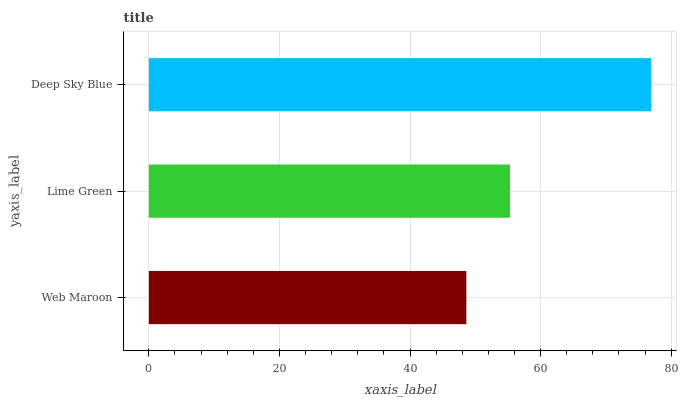Is Web Maroon the minimum?
Answer yes or no. Yes. Is Deep Sky Blue the maximum?
Answer yes or no. Yes. Is Lime Green the minimum?
Answer yes or no. No. Is Lime Green the maximum?
Answer yes or no. No. Is Lime Green greater than Web Maroon?
Answer yes or no. Yes. Is Web Maroon less than Lime Green?
Answer yes or no. Yes. Is Web Maroon greater than Lime Green?
Answer yes or no. No. Is Lime Green less than Web Maroon?
Answer yes or no. No. Is Lime Green the high median?
Answer yes or no. Yes. Is Lime Green the low median?
Answer yes or no. Yes. Is Web Maroon the high median?
Answer yes or no. No. Is Web Maroon the low median?
Answer yes or no. No. 